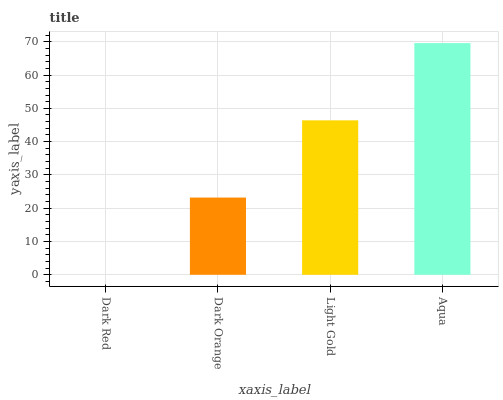Is Dark Orange the minimum?
Answer yes or no. No. Is Dark Orange the maximum?
Answer yes or no. No. Is Dark Orange greater than Dark Red?
Answer yes or no. Yes. Is Dark Red less than Dark Orange?
Answer yes or no. Yes. Is Dark Red greater than Dark Orange?
Answer yes or no. No. Is Dark Orange less than Dark Red?
Answer yes or no. No. Is Light Gold the high median?
Answer yes or no. Yes. Is Dark Orange the low median?
Answer yes or no. Yes. Is Dark Red the high median?
Answer yes or no. No. Is Dark Red the low median?
Answer yes or no. No. 